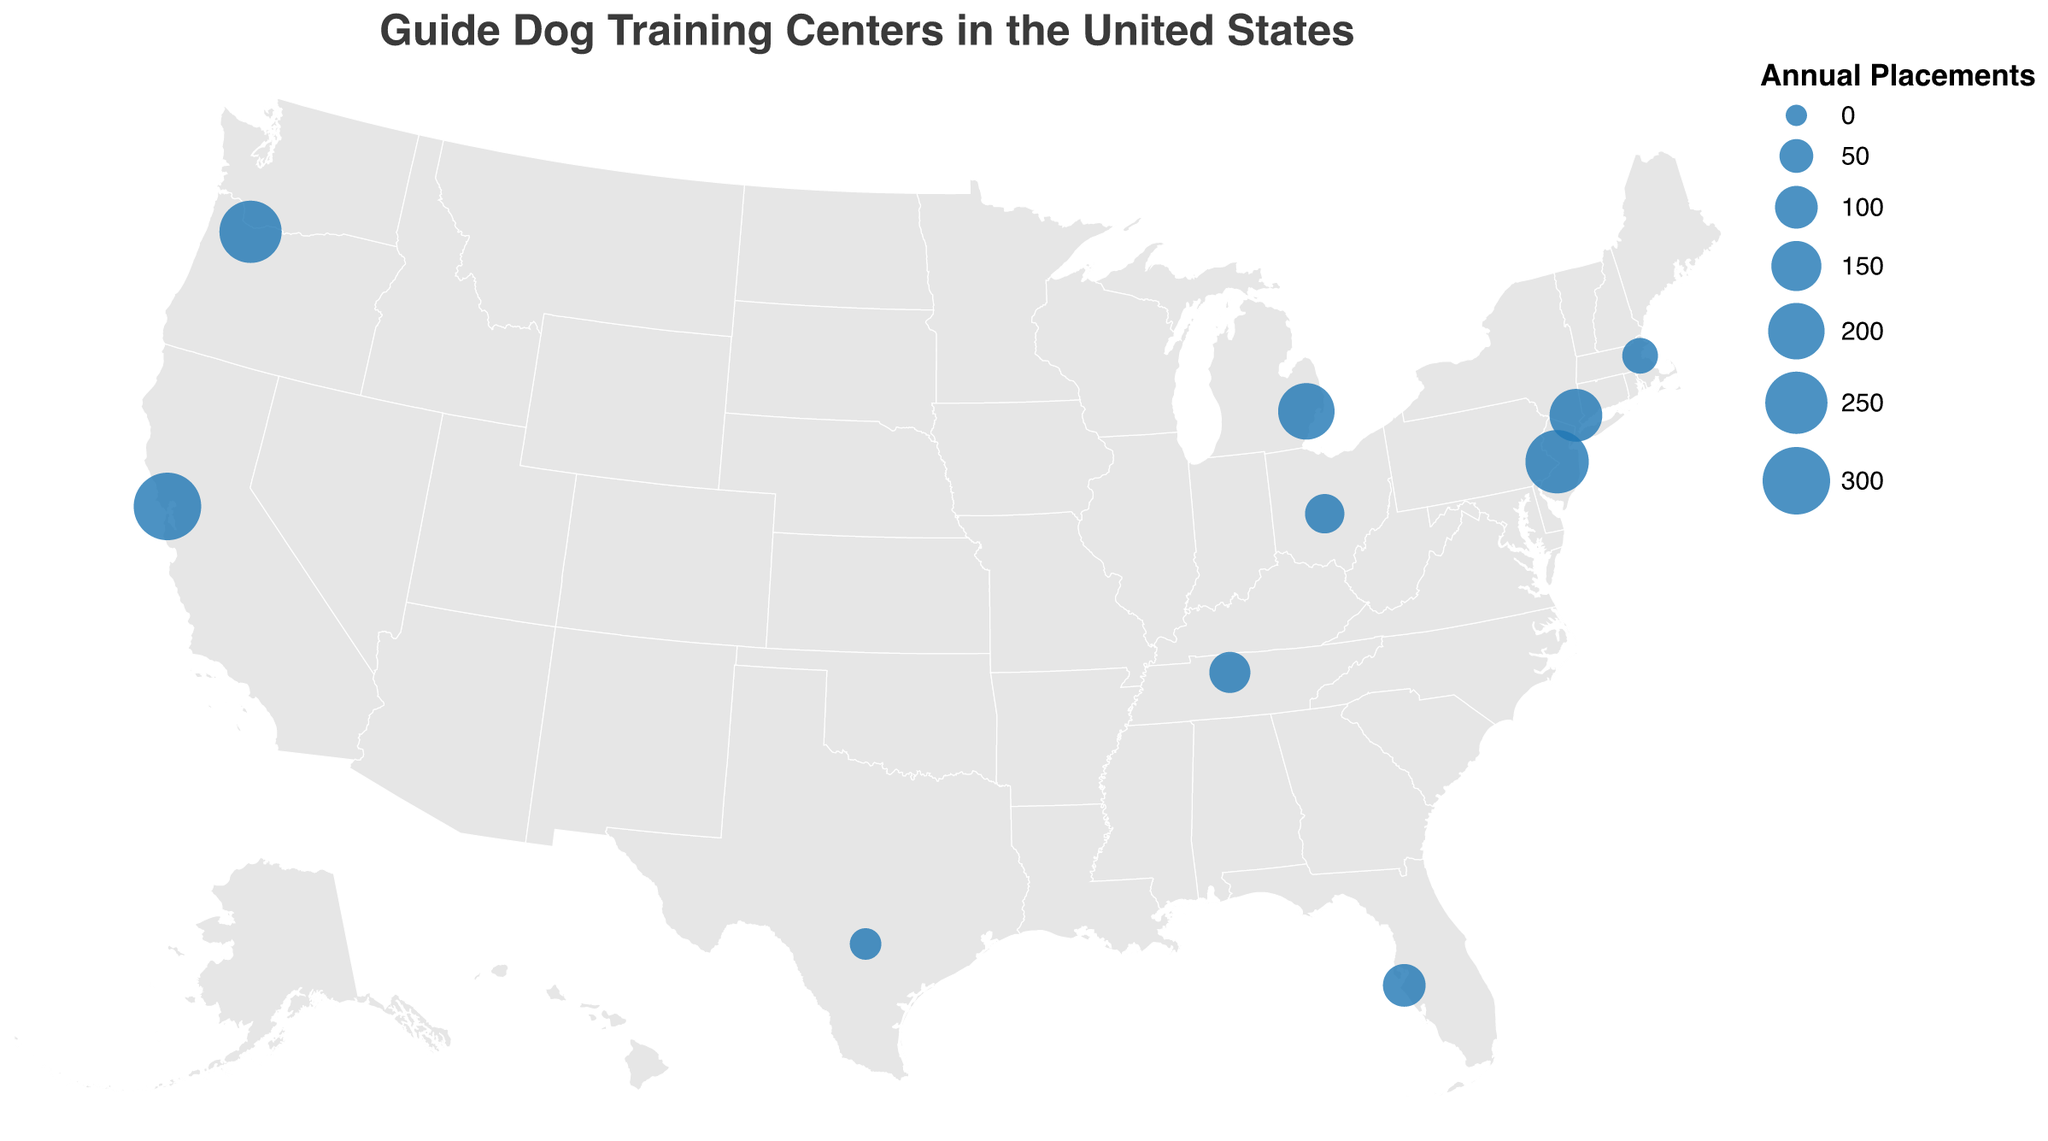what is the title of the figure? The title is placed at the top center of the figure and the text is large and clear: 'Guide Dog Training Centers in the United States'.
Answer: Guide Dog Training Centers in the United States how many guide dog training centers are represented in the figure? Count the number of data points (circles) on the map. There are dots representing the training centers across the various states.
Answer: 10 which center has the highest annual placements? Look for the largest circle on the map, which represents the center with the highest annual placements. According to the tooltip or legend, the largest circle corresponds to Guide Dogs for the Blind in San Rafael, California.
Answer: Guide Dogs for the Blind in San Rafael, California what are the annual placements for the training center in New York? Hover over the circle in New York (Yorktown Heights) and refer to the tooltip which provides the information.
Answer: 170 which states have more than one guide dog training center? Identify and match the states from the map that have multiple circles representing different training centers. The circles' tooltips and locations help determine this.
Answer: California what is the combined annual placements for all guide dog training centers in California? Identify the two centers in California (San Rafael: 300, and Boring: 250), and sum their annual placements: 300 + 250. The total then is 550.
Answer: 550 how many centers have annual placements of more than 200? Look for all circles that are relatively large, indicating centers with annual placements greater than 200, then count these circles. There's one in San Rafael (300), one in Boring (250), and one in Morrisville (260). The number is three.
Answer: 3 which coast (East or West) appears to have higher total annual placements? Sum the annual placements of the centers on the East Coast (New York: 170, Florida: 100, Massachusetts: 60, Pennsylvania: 260) and those on the West Coast (California: 300, Oregon: 250). Compare their totals East: 590, West: 550. The East Coast has a slightly higher number.
Answer: East Coast what is the average annual placements across all training centers? Sum all the provided annual placements and then divide by the number of centers. (300 + 170 + 100 + 200 + 250 + 80 + 60 + 90 + 40 + 260) / 10. The total sum is 1550, thus the average is 1550/10 = 155.
Answer: 155 which state's guide dog training center has the lowest annual placements and what is it? Locate the smallest circle on the map, and refer to the tooltip. It corresponds to the center in Texas (San Antonio: 40 annual placements).
Answer: Texas, 40 